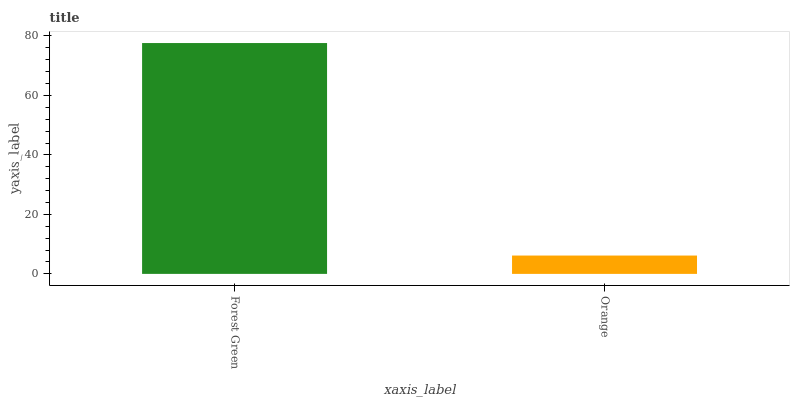Is Orange the maximum?
Answer yes or no. No. Is Forest Green greater than Orange?
Answer yes or no. Yes. Is Orange less than Forest Green?
Answer yes or no. Yes. Is Orange greater than Forest Green?
Answer yes or no. No. Is Forest Green less than Orange?
Answer yes or no. No. Is Forest Green the high median?
Answer yes or no. Yes. Is Orange the low median?
Answer yes or no. Yes. Is Orange the high median?
Answer yes or no. No. Is Forest Green the low median?
Answer yes or no. No. 